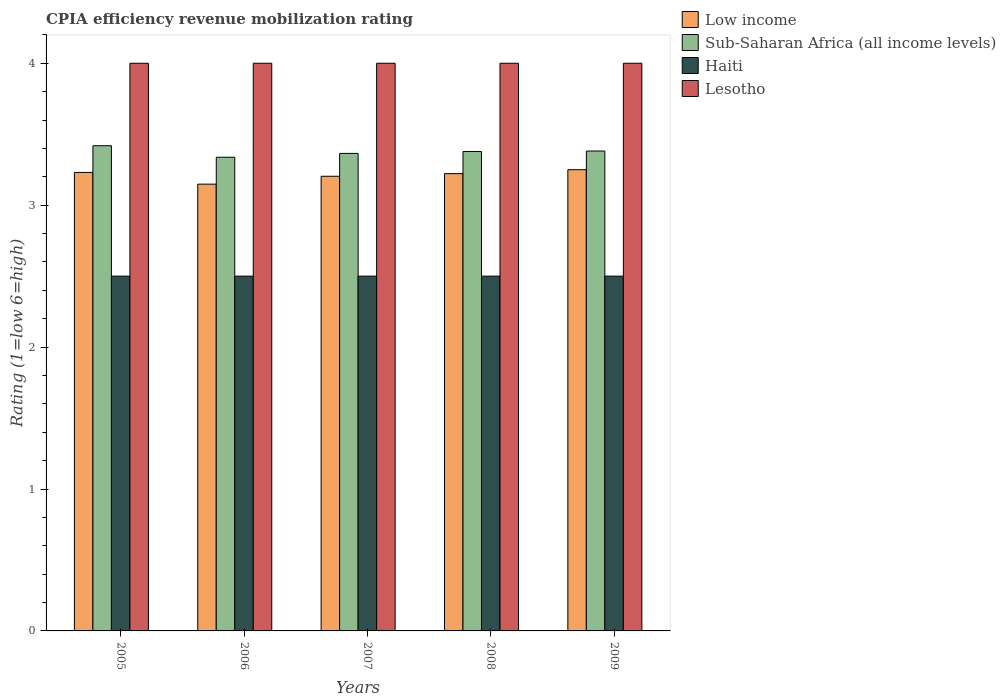How many different coloured bars are there?
Provide a succinct answer. 4. Are the number of bars on each tick of the X-axis equal?
Your answer should be very brief. Yes. How many bars are there on the 5th tick from the left?
Your response must be concise. 4. How many bars are there on the 2nd tick from the right?
Give a very brief answer. 4. In how many cases, is the number of bars for a given year not equal to the number of legend labels?
Ensure brevity in your answer.  0. What is the CPIA rating in Lesotho in 2006?
Provide a short and direct response. 4. Across all years, what is the maximum CPIA rating in Lesotho?
Your answer should be compact. 4. Across all years, what is the minimum CPIA rating in Lesotho?
Give a very brief answer. 4. In which year was the CPIA rating in Sub-Saharan Africa (all income levels) maximum?
Your response must be concise. 2005. What is the total CPIA rating in Sub-Saharan Africa (all income levels) in the graph?
Ensure brevity in your answer.  16.88. What is the difference between the CPIA rating in Sub-Saharan Africa (all income levels) in 2005 and that in 2009?
Provide a short and direct response. 0.04. What is the difference between the CPIA rating in Lesotho in 2008 and the CPIA rating in Haiti in 2007?
Make the answer very short. 1.5. What is the average CPIA rating in Haiti per year?
Offer a terse response. 2.5. In the year 2009, what is the difference between the CPIA rating in Sub-Saharan Africa (all income levels) and CPIA rating in Haiti?
Your response must be concise. 0.88. In how many years, is the CPIA rating in Lesotho greater than 3.4?
Keep it short and to the point. 5. What is the ratio of the CPIA rating in Low income in 2006 to that in 2007?
Your answer should be compact. 0.98. What is the difference between the highest and the second highest CPIA rating in Haiti?
Give a very brief answer. 0. What is the difference between the highest and the lowest CPIA rating in Lesotho?
Keep it short and to the point. 0. What does the 2nd bar from the left in 2005 represents?
Offer a terse response. Sub-Saharan Africa (all income levels). What does the 2nd bar from the right in 2008 represents?
Your response must be concise. Haiti. How many years are there in the graph?
Offer a very short reply. 5. Does the graph contain grids?
Offer a terse response. No. Where does the legend appear in the graph?
Provide a short and direct response. Top right. How many legend labels are there?
Provide a short and direct response. 4. How are the legend labels stacked?
Provide a succinct answer. Vertical. What is the title of the graph?
Ensure brevity in your answer.  CPIA efficiency revenue mobilization rating. Does "Australia" appear as one of the legend labels in the graph?
Offer a very short reply. No. What is the label or title of the X-axis?
Make the answer very short. Years. What is the Rating (1=low 6=high) in Low income in 2005?
Your response must be concise. 3.23. What is the Rating (1=low 6=high) of Sub-Saharan Africa (all income levels) in 2005?
Your answer should be very brief. 3.42. What is the Rating (1=low 6=high) of Haiti in 2005?
Provide a succinct answer. 2.5. What is the Rating (1=low 6=high) of Lesotho in 2005?
Keep it short and to the point. 4. What is the Rating (1=low 6=high) in Low income in 2006?
Give a very brief answer. 3.15. What is the Rating (1=low 6=high) in Sub-Saharan Africa (all income levels) in 2006?
Offer a terse response. 3.34. What is the Rating (1=low 6=high) in Haiti in 2006?
Offer a terse response. 2.5. What is the Rating (1=low 6=high) in Low income in 2007?
Provide a short and direct response. 3.2. What is the Rating (1=low 6=high) of Sub-Saharan Africa (all income levels) in 2007?
Keep it short and to the point. 3.36. What is the Rating (1=low 6=high) of Low income in 2008?
Give a very brief answer. 3.22. What is the Rating (1=low 6=high) in Sub-Saharan Africa (all income levels) in 2008?
Provide a short and direct response. 3.38. What is the Rating (1=low 6=high) of Sub-Saharan Africa (all income levels) in 2009?
Give a very brief answer. 3.38. What is the Rating (1=low 6=high) of Haiti in 2009?
Provide a short and direct response. 2.5. Across all years, what is the maximum Rating (1=low 6=high) of Low income?
Provide a short and direct response. 3.25. Across all years, what is the maximum Rating (1=low 6=high) of Sub-Saharan Africa (all income levels)?
Ensure brevity in your answer.  3.42. Across all years, what is the maximum Rating (1=low 6=high) in Haiti?
Make the answer very short. 2.5. Across all years, what is the minimum Rating (1=low 6=high) of Low income?
Offer a very short reply. 3.15. Across all years, what is the minimum Rating (1=low 6=high) in Sub-Saharan Africa (all income levels)?
Offer a very short reply. 3.34. Across all years, what is the minimum Rating (1=low 6=high) in Haiti?
Make the answer very short. 2.5. What is the total Rating (1=low 6=high) of Low income in the graph?
Provide a succinct answer. 16.05. What is the total Rating (1=low 6=high) in Sub-Saharan Africa (all income levels) in the graph?
Provide a short and direct response. 16.88. What is the difference between the Rating (1=low 6=high) in Low income in 2005 and that in 2006?
Your answer should be compact. 0.08. What is the difference between the Rating (1=low 6=high) of Sub-Saharan Africa (all income levels) in 2005 and that in 2006?
Your answer should be very brief. 0.08. What is the difference between the Rating (1=low 6=high) in Haiti in 2005 and that in 2006?
Provide a short and direct response. 0. What is the difference between the Rating (1=low 6=high) in Lesotho in 2005 and that in 2006?
Your answer should be very brief. 0. What is the difference between the Rating (1=low 6=high) in Low income in 2005 and that in 2007?
Provide a short and direct response. 0.03. What is the difference between the Rating (1=low 6=high) of Sub-Saharan Africa (all income levels) in 2005 and that in 2007?
Make the answer very short. 0.05. What is the difference between the Rating (1=low 6=high) in Lesotho in 2005 and that in 2007?
Your response must be concise. 0. What is the difference between the Rating (1=low 6=high) of Low income in 2005 and that in 2008?
Your answer should be very brief. 0.01. What is the difference between the Rating (1=low 6=high) of Sub-Saharan Africa (all income levels) in 2005 and that in 2008?
Give a very brief answer. 0.04. What is the difference between the Rating (1=low 6=high) in Haiti in 2005 and that in 2008?
Your answer should be compact. 0. What is the difference between the Rating (1=low 6=high) of Lesotho in 2005 and that in 2008?
Provide a succinct answer. 0. What is the difference between the Rating (1=low 6=high) in Low income in 2005 and that in 2009?
Keep it short and to the point. -0.02. What is the difference between the Rating (1=low 6=high) of Sub-Saharan Africa (all income levels) in 2005 and that in 2009?
Provide a short and direct response. 0.04. What is the difference between the Rating (1=low 6=high) of Lesotho in 2005 and that in 2009?
Make the answer very short. 0. What is the difference between the Rating (1=low 6=high) of Low income in 2006 and that in 2007?
Make the answer very short. -0.06. What is the difference between the Rating (1=low 6=high) in Sub-Saharan Africa (all income levels) in 2006 and that in 2007?
Ensure brevity in your answer.  -0.03. What is the difference between the Rating (1=low 6=high) in Haiti in 2006 and that in 2007?
Offer a very short reply. 0. What is the difference between the Rating (1=low 6=high) in Lesotho in 2006 and that in 2007?
Give a very brief answer. 0. What is the difference between the Rating (1=low 6=high) in Low income in 2006 and that in 2008?
Ensure brevity in your answer.  -0.07. What is the difference between the Rating (1=low 6=high) of Sub-Saharan Africa (all income levels) in 2006 and that in 2008?
Give a very brief answer. -0.04. What is the difference between the Rating (1=low 6=high) of Lesotho in 2006 and that in 2008?
Keep it short and to the point. 0. What is the difference between the Rating (1=low 6=high) of Low income in 2006 and that in 2009?
Make the answer very short. -0.1. What is the difference between the Rating (1=low 6=high) in Sub-Saharan Africa (all income levels) in 2006 and that in 2009?
Provide a succinct answer. -0.04. What is the difference between the Rating (1=low 6=high) of Haiti in 2006 and that in 2009?
Give a very brief answer. 0. What is the difference between the Rating (1=low 6=high) of Lesotho in 2006 and that in 2009?
Keep it short and to the point. 0. What is the difference between the Rating (1=low 6=high) of Low income in 2007 and that in 2008?
Offer a terse response. -0.02. What is the difference between the Rating (1=low 6=high) of Sub-Saharan Africa (all income levels) in 2007 and that in 2008?
Make the answer very short. -0.01. What is the difference between the Rating (1=low 6=high) in Haiti in 2007 and that in 2008?
Make the answer very short. 0. What is the difference between the Rating (1=low 6=high) of Low income in 2007 and that in 2009?
Your response must be concise. -0.05. What is the difference between the Rating (1=low 6=high) in Sub-Saharan Africa (all income levels) in 2007 and that in 2009?
Give a very brief answer. -0.02. What is the difference between the Rating (1=low 6=high) in Lesotho in 2007 and that in 2009?
Make the answer very short. 0. What is the difference between the Rating (1=low 6=high) in Low income in 2008 and that in 2009?
Make the answer very short. -0.03. What is the difference between the Rating (1=low 6=high) in Sub-Saharan Africa (all income levels) in 2008 and that in 2009?
Your answer should be compact. -0. What is the difference between the Rating (1=low 6=high) of Lesotho in 2008 and that in 2009?
Keep it short and to the point. 0. What is the difference between the Rating (1=low 6=high) in Low income in 2005 and the Rating (1=low 6=high) in Sub-Saharan Africa (all income levels) in 2006?
Make the answer very short. -0.11. What is the difference between the Rating (1=low 6=high) of Low income in 2005 and the Rating (1=low 6=high) of Haiti in 2006?
Offer a very short reply. 0.73. What is the difference between the Rating (1=low 6=high) of Low income in 2005 and the Rating (1=low 6=high) of Lesotho in 2006?
Ensure brevity in your answer.  -0.77. What is the difference between the Rating (1=low 6=high) of Sub-Saharan Africa (all income levels) in 2005 and the Rating (1=low 6=high) of Haiti in 2006?
Ensure brevity in your answer.  0.92. What is the difference between the Rating (1=low 6=high) of Sub-Saharan Africa (all income levels) in 2005 and the Rating (1=low 6=high) of Lesotho in 2006?
Keep it short and to the point. -0.58. What is the difference between the Rating (1=low 6=high) in Low income in 2005 and the Rating (1=low 6=high) in Sub-Saharan Africa (all income levels) in 2007?
Make the answer very short. -0.13. What is the difference between the Rating (1=low 6=high) of Low income in 2005 and the Rating (1=low 6=high) of Haiti in 2007?
Make the answer very short. 0.73. What is the difference between the Rating (1=low 6=high) of Low income in 2005 and the Rating (1=low 6=high) of Lesotho in 2007?
Provide a succinct answer. -0.77. What is the difference between the Rating (1=low 6=high) of Sub-Saharan Africa (all income levels) in 2005 and the Rating (1=low 6=high) of Haiti in 2007?
Ensure brevity in your answer.  0.92. What is the difference between the Rating (1=low 6=high) of Sub-Saharan Africa (all income levels) in 2005 and the Rating (1=low 6=high) of Lesotho in 2007?
Offer a terse response. -0.58. What is the difference between the Rating (1=low 6=high) of Haiti in 2005 and the Rating (1=low 6=high) of Lesotho in 2007?
Give a very brief answer. -1.5. What is the difference between the Rating (1=low 6=high) of Low income in 2005 and the Rating (1=low 6=high) of Sub-Saharan Africa (all income levels) in 2008?
Your answer should be very brief. -0.15. What is the difference between the Rating (1=low 6=high) of Low income in 2005 and the Rating (1=low 6=high) of Haiti in 2008?
Provide a succinct answer. 0.73. What is the difference between the Rating (1=low 6=high) in Low income in 2005 and the Rating (1=low 6=high) in Lesotho in 2008?
Offer a very short reply. -0.77. What is the difference between the Rating (1=low 6=high) in Sub-Saharan Africa (all income levels) in 2005 and the Rating (1=low 6=high) in Haiti in 2008?
Offer a very short reply. 0.92. What is the difference between the Rating (1=low 6=high) in Sub-Saharan Africa (all income levels) in 2005 and the Rating (1=low 6=high) in Lesotho in 2008?
Offer a very short reply. -0.58. What is the difference between the Rating (1=low 6=high) of Haiti in 2005 and the Rating (1=low 6=high) of Lesotho in 2008?
Make the answer very short. -1.5. What is the difference between the Rating (1=low 6=high) of Low income in 2005 and the Rating (1=low 6=high) of Sub-Saharan Africa (all income levels) in 2009?
Provide a short and direct response. -0.15. What is the difference between the Rating (1=low 6=high) in Low income in 2005 and the Rating (1=low 6=high) in Haiti in 2009?
Keep it short and to the point. 0.73. What is the difference between the Rating (1=low 6=high) in Low income in 2005 and the Rating (1=low 6=high) in Lesotho in 2009?
Your answer should be compact. -0.77. What is the difference between the Rating (1=low 6=high) in Sub-Saharan Africa (all income levels) in 2005 and the Rating (1=low 6=high) in Haiti in 2009?
Offer a terse response. 0.92. What is the difference between the Rating (1=low 6=high) in Sub-Saharan Africa (all income levels) in 2005 and the Rating (1=low 6=high) in Lesotho in 2009?
Provide a short and direct response. -0.58. What is the difference between the Rating (1=low 6=high) in Haiti in 2005 and the Rating (1=low 6=high) in Lesotho in 2009?
Provide a succinct answer. -1.5. What is the difference between the Rating (1=low 6=high) in Low income in 2006 and the Rating (1=low 6=high) in Sub-Saharan Africa (all income levels) in 2007?
Your answer should be compact. -0.22. What is the difference between the Rating (1=low 6=high) of Low income in 2006 and the Rating (1=low 6=high) of Haiti in 2007?
Make the answer very short. 0.65. What is the difference between the Rating (1=low 6=high) of Low income in 2006 and the Rating (1=low 6=high) of Lesotho in 2007?
Ensure brevity in your answer.  -0.85. What is the difference between the Rating (1=low 6=high) in Sub-Saharan Africa (all income levels) in 2006 and the Rating (1=low 6=high) in Haiti in 2007?
Your answer should be very brief. 0.84. What is the difference between the Rating (1=low 6=high) in Sub-Saharan Africa (all income levels) in 2006 and the Rating (1=low 6=high) in Lesotho in 2007?
Offer a terse response. -0.66. What is the difference between the Rating (1=low 6=high) in Haiti in 2006 and the Rating (1=low 6=high) in Lesotho in 2007?
Keep it short and to the point. -1.5. What is the difference between the Rating (1=low 6=high) in Low income in 2006 and the Rating (1=low 6=high) in Sub-Saharan Africa (all income levels) in 2008?
Your response must be concise. -0.23. What is the difference between the Rating (1=low 6=high) in Low income in 2006 and the Rating (1=low 6=high) in Haiti in 2008?
Your answer should be very brief. 0.65. What is the difference between the Rating (1=low 6=high) in Low income in 2006 and the Rating (1=low 6=high) in Lesotho in 2008?
Offer a very short reply. -0.85. What is the difference between the Rating (1=low 6=high) in Sub-Saharan Africa (all income levels) in 2006 and the Rating (1=low 6=high) in Haiti in 2008?
Your answer should be very brief. 0.84. What is the difference between the Rating (1=low 6=high) of Sub-Saharan Africa (all income levels) in 2006 and the Rating (1=low 6=high) of Lesotho in 2008?
Provide a short and direct response. -0.66. What is the difference between the Rating (1=low 6=high) in Haiti in 2006 and the Rating (1=low 6=high) in Lesotho in 2008?
Keep it short and to the point. -1.5. What is the difference between the Rating (1=low 6=high) of Low income in 2006 and the Rating (1=low 6=high) of Sub-Saharan Africa (all income levels) in 2009?
Ensure brevity in your answer.  -0.23. What is the difference between the Rating (1=low 6=high) in Low income in 2006 and the Rating (1=low 6=high) in Haiti in 2009?
Keep it short and to the point. 0.65. What is the difference between the Rating (1=low 6=high) of Low income in 2006 and the Rating (1=low 6=high) of Lesotho in 2009?
Offer a terse response. -0.85. What is the difference between the Rating (1=low 6=high) in Sub-Saharan Africa (all income levels) in 2006 and the Rating (1=low 6=high) in Haiti in 2009?
Keep it short and to the point. 0.84. What is the difference between the Rating (1=low 6=high) in Sub-Saharan Africa (all income levels) in 2006 and the Rating (1=low 6=high) in Lesotho in 2009?
Keep it short and to the point. -0.66. What is the difference between the Rating (1=low 6=high) of Low income in 2007 and the Rating (1=low 6=high) of Sub-Saharan Africa (all income levels) in 2008?
Keep it short and to the point. -0.17. What is the difference between the Rating (1=low 6=high) of Low income in 2007 and the Rating (1=low 6=high) of Haiti in 2008?
Provide a succinct answer. 0.7. What is the difference between the Rating (1=low 6=high) in Low income in 2007 and the Rating (1=low 6=high) in Lesotho in 2008?
Offer a terse response. -0.8. What is the difference between the Rating (1=low 6=high) in Sub-Saharan Africa (all income levels) in 2007 and the Rating (1=low 6=high) in Haiti in 2008?
Ensure brevity in your answer.  0.86. What is the difference between the Rating (1=low 6=high) in Sub-Saharan Africa (all income levels) in 2007 and the Rating (1=low 6=high) in Lesotho in 2008?
Give a very brief answer. -0.64. What is the difference between the Rating (1=low 6=high) in Low income in 2007 and the Rating (1=low 6=high) in Sub-Saharan Africa (all income levels) in 2009?
Your answer should be very brief. -0.18. What is the difference between the Rating (1=low 6=high) of Low income in 2007 and the Rating (1=low 6=high) of Haiti in 2009?
Keep it short and to the point. 0.7. What is the difference between the Rating (1=low 6=high) in Low income in 2007 and the Rating (1=low 6=high) in Lesotho in 2009?
Provide a short and direct response. -0.8. What is the difference between the Rating (1=low 6=high) in Sub-Saharan Africa (all income levels) in 2007 and the Rating (1=low 6=high) in Haiti in 2009?
Offer a terse response. 0.86. What is the difference between the Rating (1=low 6=high) in Sub-Saharan Africa (all income levels) in 2007 and the Rating (1=low 6=high) in Lesotho in 2009?
Keep it short and to the point. -0.64. What is the difference between the Rating (1=low 6=high) of Low income in 2008 and the Rating (1=low 6=high) of Sub-Saharan Africa (all income levels) in 2009?
Your answer should be very brief. -0.16. What is the difference between the Rating (1=low 6=high) in Low income in 2008 and the Rating (1=low 6=high) in Haiti in 2009?
Make the answer very short. 0.72. What is the difference between the Rating (1=low 6=high) of Low income in 2008 and the Rating (1=low 6=high) of Lesotho in 2009?
Ensure brevity in your answer.  -0.78. What is the difference between the Rating (1=low 6=high) of Sub-Saharan Africa (all income levels) in 2008 and the Rating (1=low 6=high) of Haiti in 2009?
Give a very brief answer. 0.88. What is the difference between the Rating (1=low 6=high) in Sub-Saharan Africa (all income levels) in 2008 and the Rating (1=low 6=high) in Lesotho in 2009?
Ensure brevity in your answer.  -0.62. What is the average Rating (1=low 6=high) of Low income per year?
Your response must be concise. 3.21. What is the average Rating (1=low 6=high) of Sub-Saharan Africa (all income levels) per year?
Provide a short and direct response. 3.38. In the year 2005, what is the difference between the Rating (1=low 6=high) in Low income and Rating (1=low 6=high) in Sub-Saharan Africa (all income levels)?
Offer a terse response. -0.19. In the year 2005, what is the difference between the Rating (1=low 6=high) of Low income and Rating (1=low 6=high) of Haiti?
Your answer should be very brief. 0.73. In the year 2005, what is the difference between the Rating (1=low 6=high) of Low income and Rating (1=low 6=high) of Lesotho?
Offer a terse response. -0.77. In the year 2005, what is the difference between the Rating (1=low 6=high) in Sub-Saharan Africa (all income levels) and Rating (1=low 6=high) in Haiti?
Provide a succinct answer. 0.92. In the year 2005, what is the difference between the Rating (1=low 6=high) of Sub-Saharan Africa (all income levels) and Rating (1=low 6=high) of Lesotho?
Make the answer very short. -0.58. In the year 2005, what is the difference between the Rating (1=low 6=high) in Haiti and Rating (1=low 6=high) in Lesotho?
Provide a short and direct response. -1.5. In the year 2006, what is the difference between the Rating (1=low 6=high) of Low income and Rating (1=low 6=high) of Sub-Saharan Africa (all income levels)?
Offer a terse response. -0.19. In the year 2006, what is the difference between the Rating (1=low 6=high) in Low income and Rating (1=low 6=high) in Haiti?
Ensure brevity in your answer.  0.65. In the year 2006, what is the difference between the Rating (1=low 6=high) in Low income and Rating (1=low 6=high) in Lesotho?
Your answer should be compact. -0.85. In the year 2006, what is the difference between the Rating (1=low 6=high) of Sub-Saharan Africa (all income levels) and Rating (1=low 6=high) of Haiti?
Provide a succinct answer. 0.84. In the year 2006, what is the difference between the Rating (1=low 6=high) in Sub-Saharan Africa (all income levels) and Rating (1=low 6=high) in Lesotho?
Your answer should be very brief. -0.66. In the year 2006, what is the difference between the Rating (1=low 6=high) of Haiti and Rating (1=low 6=high) of Lesotho?
Your response must be concise. -1.5. In the year 2007, what is the difference between the Rating (1=low 6=high) of Low income and Rating (1=low 6=high) of Sub-Saharan Africa (all income levels)?
Offer a terse response. -0.16. In the year 2007, what is the difference between the Rating (1=low 6=high) of Low income and Rating (1=low 6=high) of Haiti?
Offer a terse response. 0.7. In the year 2007, what is the difference between the Rating (1=low 6=high) in Low income and Rating (1=low 6=high) in Lesotho?
Ensure brevity in your answer.  -0.8. In the year 2007, what is the difference between the Rating (1=low 6=high) of Sub-Saharan Africa (all income levels) and Rating (1=low 6=high) of Haiti?
Your answer should be compact. 0.86. In the year 2007, what is the difference between the Rating (1=low 6=high) in Sub-Saharan Africa (all income levels) and Rating (1=low 6=high) in Lesotho?
Offer a very short reply. -0.64. In the year 2008, what is the difference between the Rating (1=low 6=high) in Low income and Rating (1=low 6=high) in Sub-Saharan Africa (all income levels)?
Your answer should be compact. -0.16. In the year 2008, what is the difference between the Rating (1=low 6=high) in Low income and Rating (1=low 6=high) in Haiti?
Your answer should be compact. 0.72. In the year 2008, what is the difference between the Rating (1=low 6=high) in Low income and Rating (1=low 6=high) in Lesotho?
Offer a very short reply. -0.78. In the year 2008, what is the difference between the Rating (1=low 6=high) in Sub-Saharan Africa (all income levels) and Rating (1=low 6=high) in Haiti?
Provide a short and direct response. 0.88. In the year 2008, what is the difference between the Rating (1=low 6=high) in Sub-Saharan Africa (all income levels) and Rating (1=low 6=high) in Lesotho?
Provide a succinct answer. -0.62. In the year 2009, what is the difference between the Rating (1=low 6=high) of Low income and Rating (1=low 6=high) of Sub-Saharan Africa (all income levels)?
Your response must be concise. -0.13. In the year 2009, what is the difference between the Rating (1=low 6=high) of Low income and Rating (1=low 6=high) of Lesotho?
Your response must be concise. -0.75. In the year 2009, what is the difference between the Rating (1=low 6=high) of Sub-Saharan Africa (all income levels) and Rating (1=low 6=high) of Haiti?
Ensure brevity in your answer.  0.88. In the year 2009, what is the difference between the Rating (1=low 6=high) of Sub-Saharan Africa (all income levels) and Rating (1=low 6=high) of Lesotho?
Ensure brevity in your answer.  -0.62. What is the ratio of the Rating (1=low 6=high) of Low income in 2005 to that in 2006?
Your answer should be compact. 1.03. What is the ratio of the Rating (1=low 6=high) in Sub-Saharan Africa (all income levels) in 2005 to that in 2006?
Offer a terse response. 1.02. What is the ratio of the Rating (1=low 6=high) in Haiti in 2005 to that in 2006?
Provide a succinct answer. 1. What is the ratio of the Rating (1=low 6=high) in Low income in 2005 to that in 2007?
Keep it short and to the point. 1.01. What is the ratio of the Rating (1=low 6=high) in Sub-Saharan Africa (all income levels) in 2005 to that in 2007?
Offer a very short reply. 1.02. What is the ratio of the Rating (1=low 6=high) in Haiti in 2005 to that in 2007?
Your answer should be compact. 1. What is the ratio of the Rating (1=low 6=high) of Lesotho in 2005 to that in 2007?
Offer a terse response. 1. What is the ratio of the Rating (1=low 6=high) of Low income in 2005 to that in 2008?
Offer a terse response. 1. What is the ratio of the Rating (1=low 6=high) of Sub-Saharan Africa (all income levels) in 2005 to that in 2009?
Make the answer very short. 1.01. What is the ratio of the Rating (1=low 6=high) in Haiti in 2005 to that in 2009?
Keep it short and to the point. 1. What is the ratio of the Rating (1=low 6=high) of Lesotho in 2005 to that in 2009?
Provide a short and direct response. 1. What is the ratio of the Rating (1=low 6=high) in Low income in 2006 to that in 2007?
Make the answer very short. 0.98. What is the ratio of the Rating (1=low 6=high) of Haiti in 2006 to that in 2007?
Give a very brief answer. 1. What is the ratio of the Rating (1=low 6=high) of Low income in 2006 to that in 2008?
Give a very brief answer. 0.98. What is the ratio of the Rating (1=low 6=high) of Sub-Saharan Africa (all income levels) in 2006 to that in 2008?
Your answer should be compact. 0.99. What is the ratio of the Rating (1=low 6=high) in Low income in 2006 to that in 2009?
Offer a terse response. 0.97. What is the ratio of the Rating (1=low 6=high) in Sub-Saharan Africa (all income levels) in 2006 to that in 2009?
Give a very brief answer. 0.99. What is the ratio of the Rating (1=low 6=high) in Haiti in 2006 to that in 2009?
Provide a short and direct response. 1. What is the ratio of the Rating (1=low 6=high) of Low income in 2007 to that in 2008?
Keep it short and to the point. 0.99. What is the ratio of the Rating (1=low 6=high) of Sub-Saharan Africa (all income levels) in 2007 to that in 2008?
Ensure brevity in your answer.  1. What is the ratio of the Rating (1=low 6=high) of Low income in 2007 to that in 2009?
Make the answer very short. 0.99. What is the ratio of the Rating (1=low 6=high) in Haiti in 2007 to that in 2009?
Keep it short and to the point. 1. What is the ratio of the Rating (1=low 6=high) in Lesotho in 2008 to that in 2009?
Your answer should be compact. 1. What is the difference between the highest and the second highest Rating (1=low 6=high) in Low income?
Keep it short and to the point. 0.02. What is the difference between the highest and the second highest Rating (1=low 6=high) of Sub-Saharan Africa (all income levels)?
Ensure brevity in your answer.  0.04. What is the difference between the highest and the second highest Rating (1=low 6=high) in Lesotho?
Make the answer very short. 0. What is the difference between the highest and the lowest Rating (1=low 6=high) in Low income?
Provide a short and direct response. 0.1. What is the difference between the highest and the lowest Rating (1=low 6=high) in Sub-Saharan Africa (all income levels)?
Your response must be concise. 0.08. 